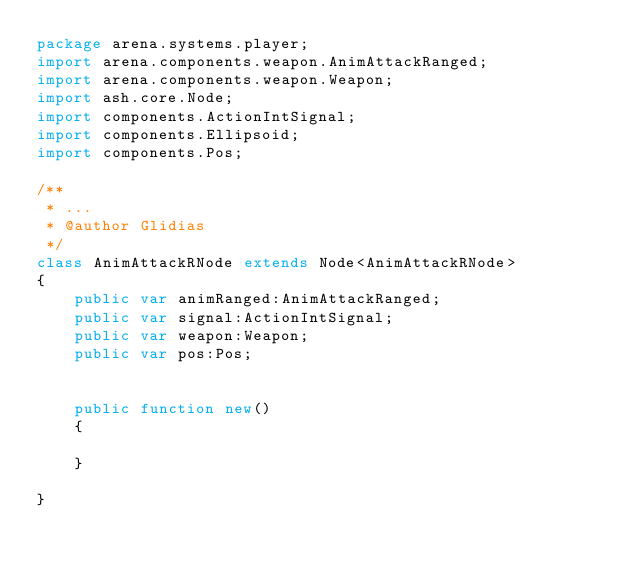<code> <loc_0><loc_0><loc_500><loc_500><_Haxe_>package arena.systems.player;
import arena.components.weapon.AnimAttackRanged;
import arena.components.weapon.Weapon;
import ash.core.Node;
import components.ActionIntSignal;
import components.Ellipsoid;
import components.Pos;

/**
 * ...
 * @author Glidias
 */
class AnimAttackRNode extends Node<AnimAttackRNode>
{
	public var animRanged:AnimAttackRanged;
	public var signal:ActionIntSignal;
	public var weapon:Weapon;
	public var pos:Pos;

	
	public function new() 
	{
		
	}
	
}</code> 